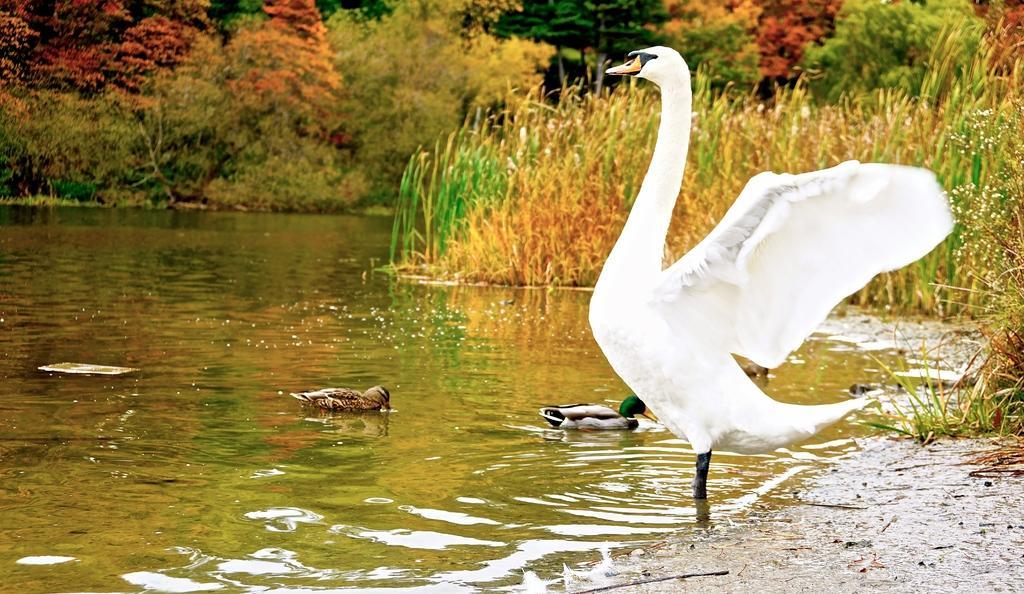Can you describe this image briefly? In this picture we can see birds, water and grass. In the background of the image we can see trees. 